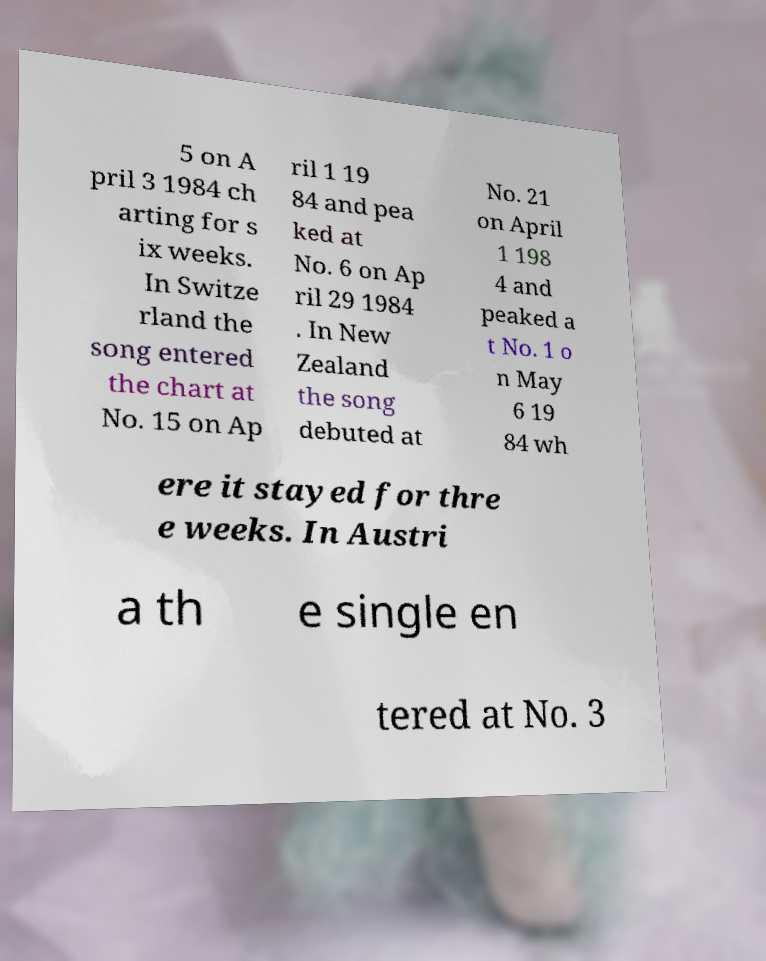Can you read and provide the text displayed in the image?This photo seems to have some interesting text. Can you extract and type it out for me? 5 on A pril 3 1984 ch arting for s ix weeks. In Switze rland the song entered the chart at No. 15 on Ap ril 1 19 84 and pea ked at No. 6 on Ap ril 29 1984 . In New Zealand the song debuted at No. 21 on April 1 198 4 and peaked a t No. 1 o n May 6 19 84 wh ere it stayed for thre e weeks. In Austri a th e single en tered at No. 3 